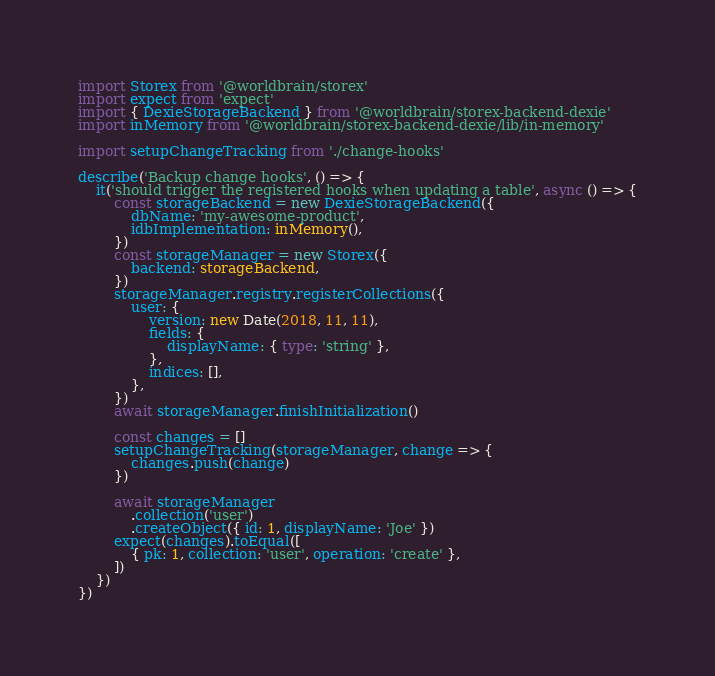<code> <loc_0><loc_0><loc_500><loc_500><_TypeScript_>import Storex from '@worldbrain/storex'
import expect from 'expect'
import { DexieStorageBackend } from '@worldbrain/storex-backend-dexie'
import inMemory from '@worldbrain/storex-backend-dexie/lib/in-memory'

import setupChangeTracking from './change-hooks'

describe('Backup change hooks', () => {
    it('should trigger the registered hooks when updating a table', async () => {
        const storageBackend = new DexieStorageBackend({
            dbName: 'my-awesome-product',
            idbImplementation: inMemory(),
        })
        const storageManager = new Storex({
            backend: storageBackend,
        })
        storageManager.registry.registerCollections({
            user: {
                version: new Date(2018, 11, 11),
                fields: {
                    displayName: { type: 'string' },
                },
                indices: [],
            },
        })
        await storageManager.finishInitialization()

        const changes = []
        setupChangeTracking(storageManager, change => {
            changes.push(change)
        })

        await storageManager
            .collection('user')
            .createObject({ id: 1, displayName: 'Joe' })
        expect(changes).toEqual([
            { pk: 1, collection: 'user', operation: 'create' },
        ])
    })
})
</code> 